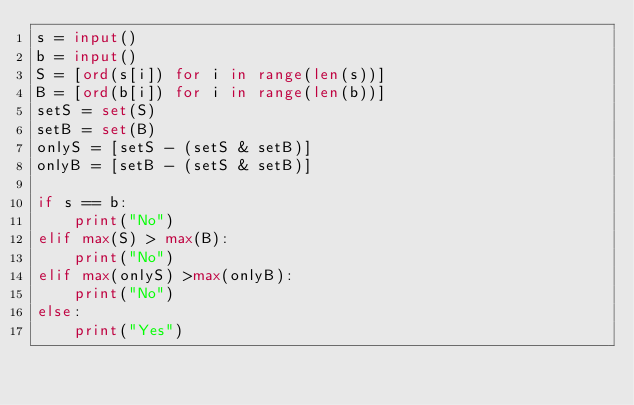Convert code to text. <code><loc_0><loc_0><loc_500><loc_500><_Python_>s = input()
b = input()
S = [ord(s[i]) for i in range(len(s))]
B = [ord(b[i]) for i in range(len(b))]
setS = set(S)
setB = set(B)
onlyS = [setS - (setS & setB)]
onlyB = [setB - (setS & setB)]

if s == b:
    print("No")
elif max(S) > max(B):
    print("No")
elif max(onlyS) >max(onlyB):
    print("No")
else:
    print("Yes")</code> 